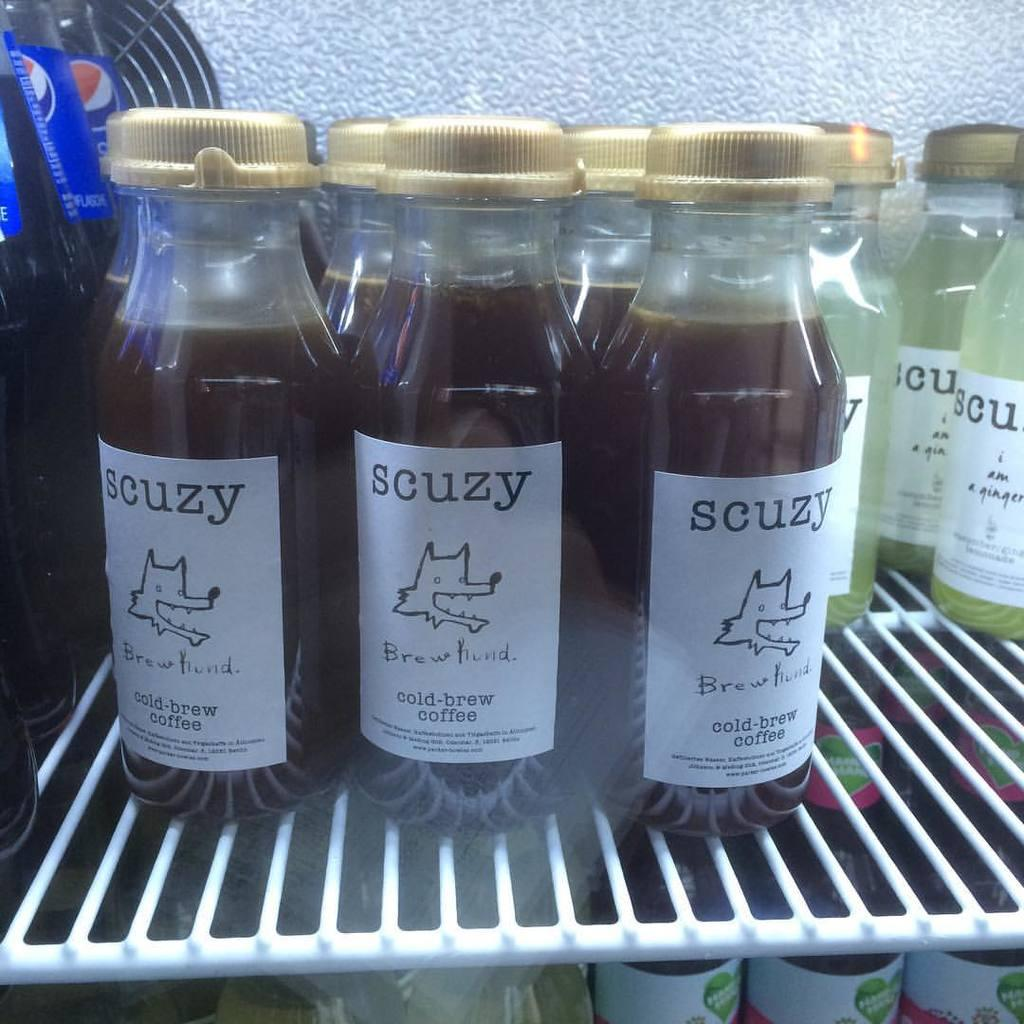<image>
Render a clear and concise summary of the photo. Many bottles of coffee from the brand scuzy are inside of a refrigerator with other drinks. 